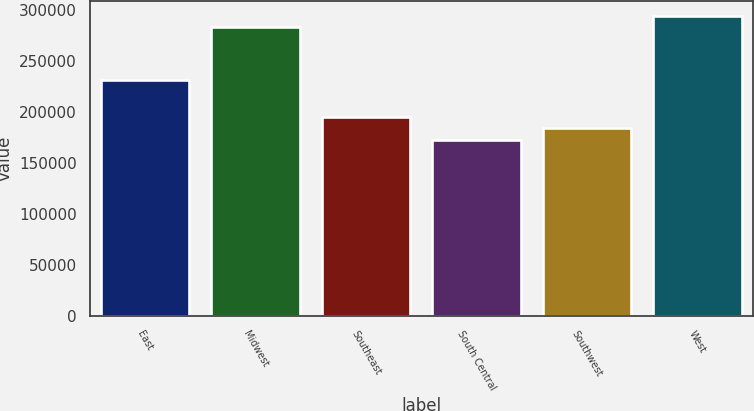<chart> <loc_0><loc_0><loc_500><loc_500><bar_chart><fcel>East<fcel>Midwest<fcel>Southeast<fcel>South Central<fcel>Southwest<fcel>West<nl><fcel>231400<fcel>283300<fcel>195280<fcel>172700<fcel>183990<fcel>294590<nl></chart> 